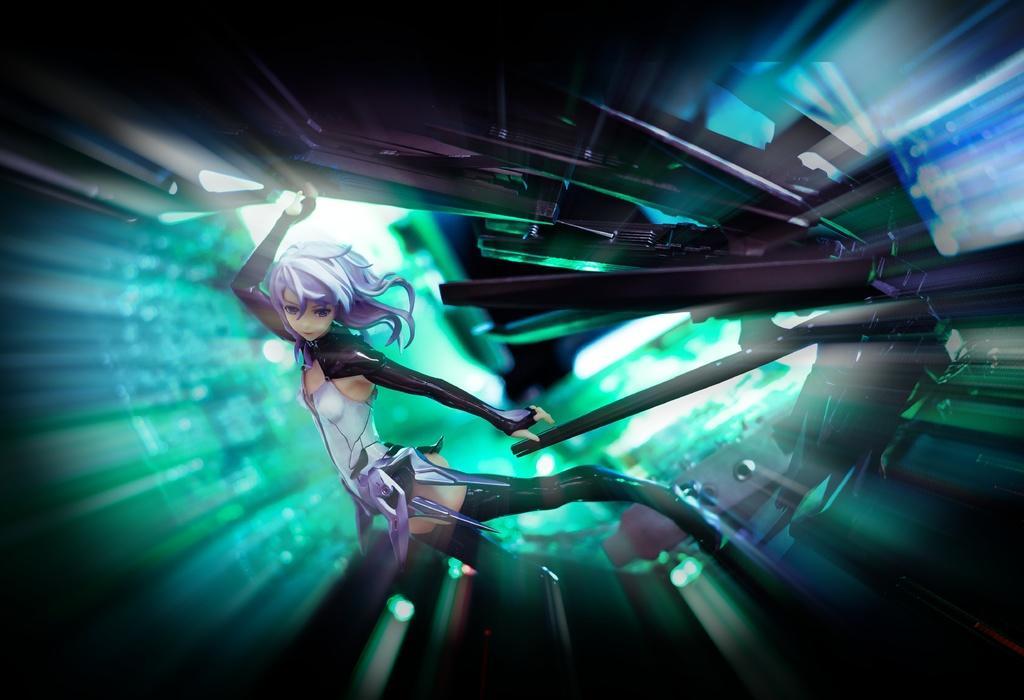Describe this image in one or two sentences. This is an animated image. On the left there is a woman seems to be standing and there are some objects in the background and we can see the light. 